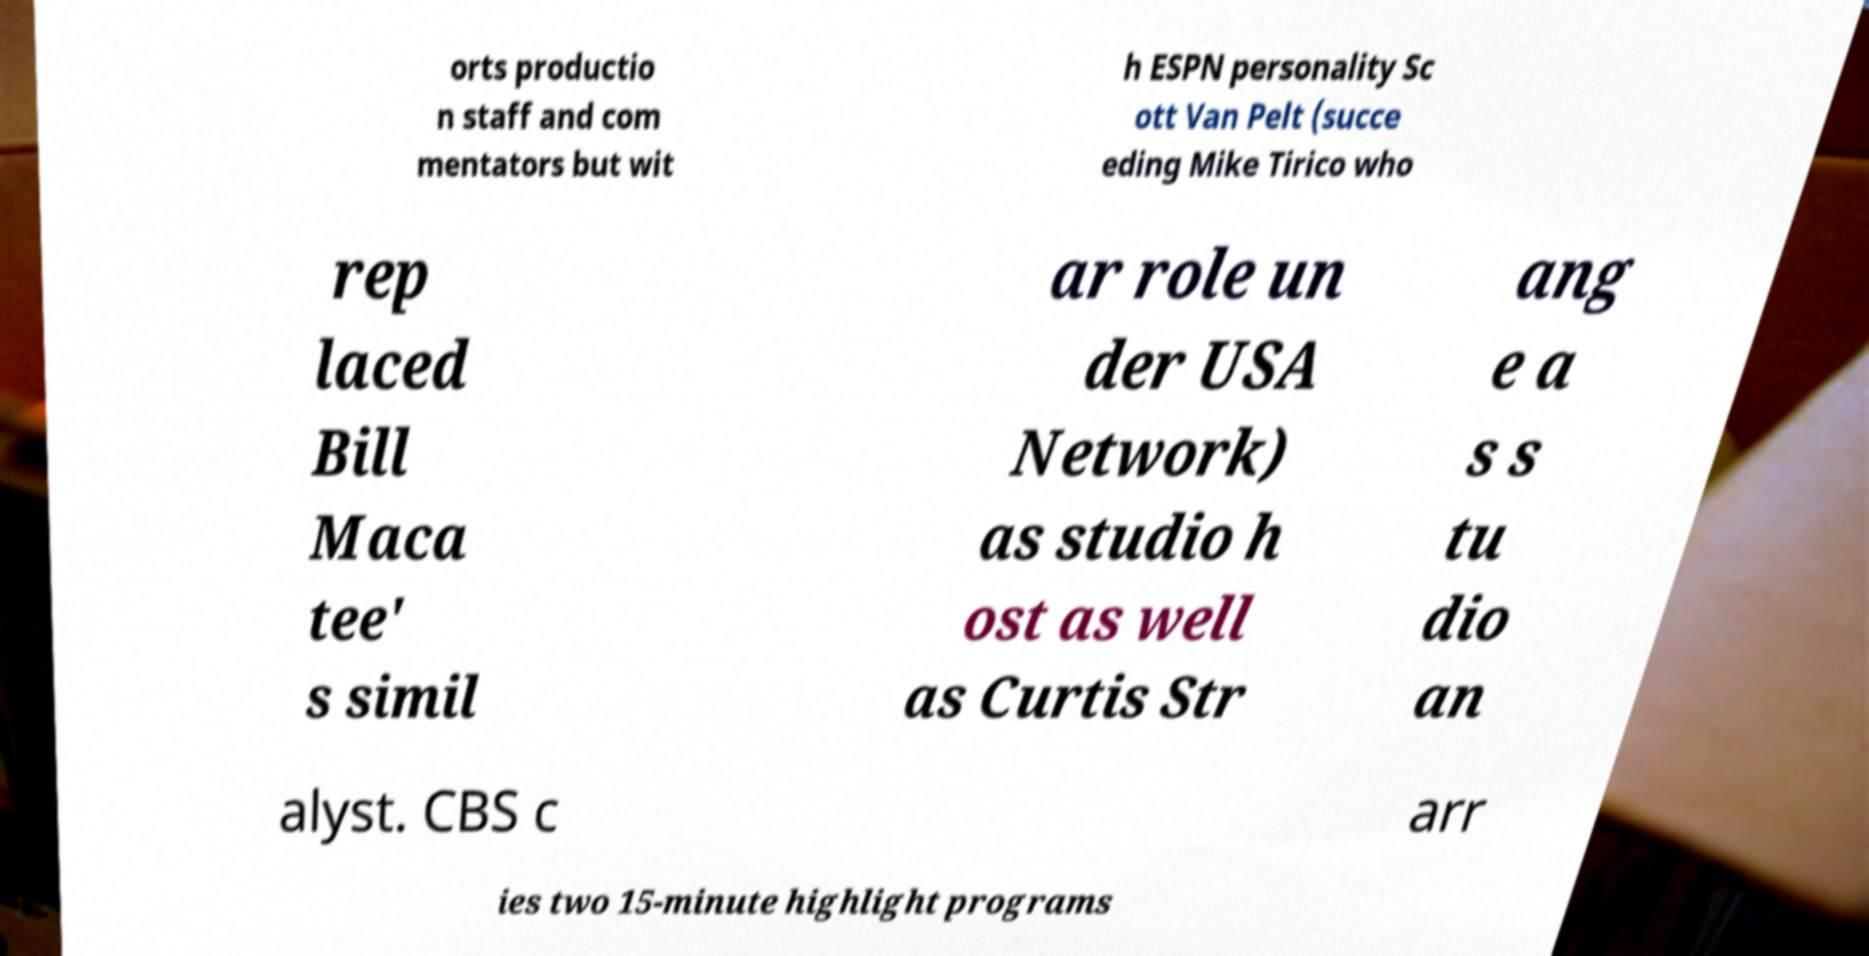What messages or text are displayed in this image? I need them in a readable, typed format. orts productio n staff and com mentators but wit h ESPN personality Sc ott Van Pelt (succe eding Mike Tirico who rep laced Bill Maca tee' s simil ar role un der USA Network) as studio h ost as well as Curtis Str ang e a s s tu dio an alyst. CBS c arr ies two 15-minute highlight programs 